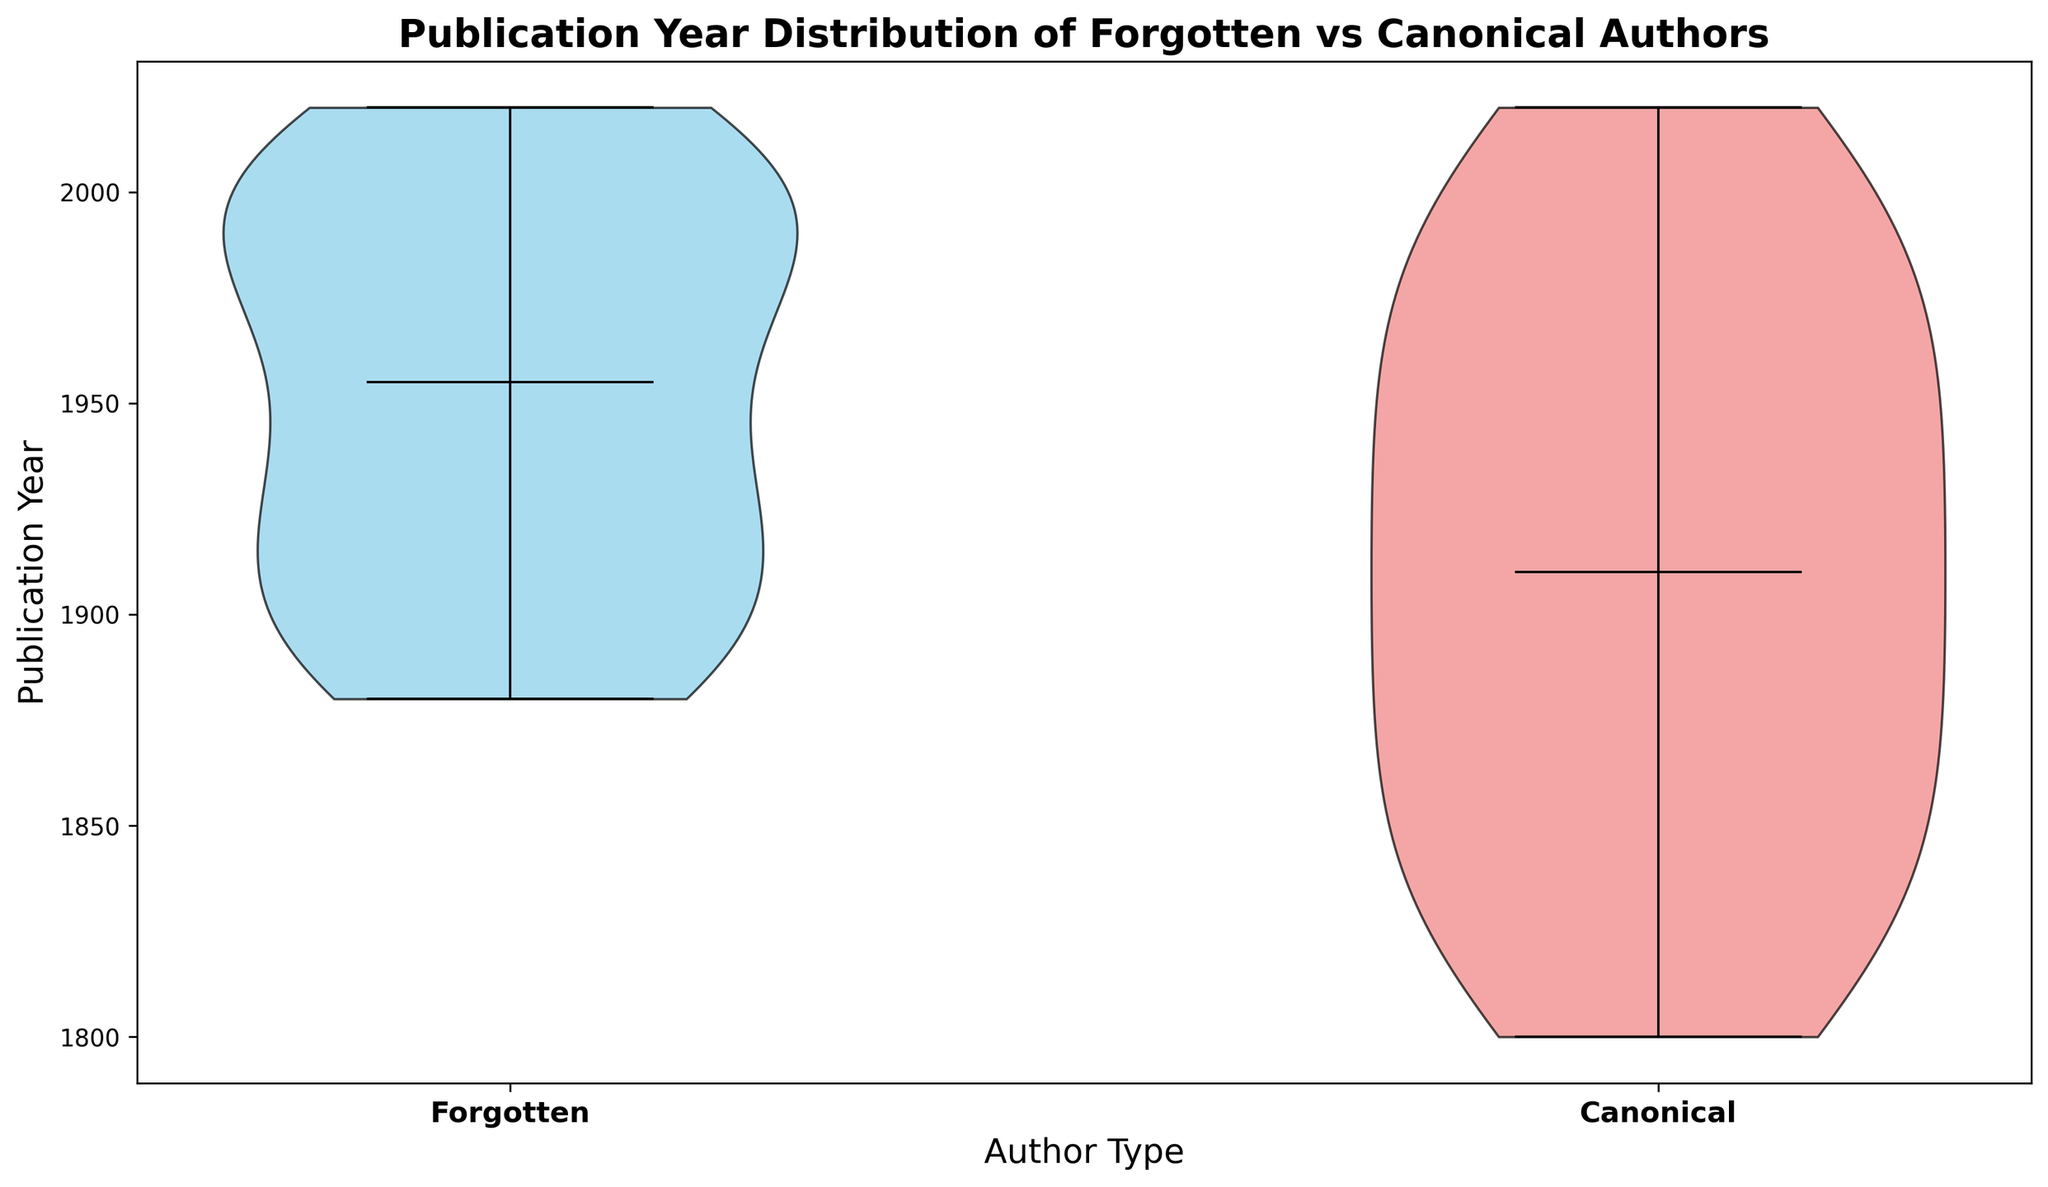What's the median publication year for Forgotten and Canonical authors? The medians can be identified from the violin plot as the points where the median line intersects. Each author type (Forgotten vs Canonical) will have a distinct median on the plot. Look at the center lines in each violin portion of the plot to find the medians for both groups. For Forgotten authors, the median is around 2000, and for Canonical authors, it is around 1900.
Answer: 2000 for Forgotten, 1900 for Canonical In which author category is there a greater spread of publication years? Spread can be observed by the width and overall length of the violin plots. Forgotten authors have publications ranging from 1880 to 2020, whereas Canonical authors have publications ranging from 1800 to 2020. However, Canonical authors have a distinctly broader distribution in the early years than the Forgotten authors.
Answer: Canonical Which author type has more concentrated recent publications? The concentration of recent publications can be identified by the density of the violin plot near the upper end of the publication years. For Forgotten authors, there is a noticeable bulge near the most recent years, indicating a higher concentration compared to Canonical authors.
Answer: Forgotten Are the publication years of Forgotten authors generally more recent compared to Canonical authors? By comparing the overall position of the violin plots along the publication year axis, we can see that the bulk (concentration) of the Forgotten authors' publications is located in more recent years compared to the Canonical authors, who have a broader distribution over older years.
Answer: Yes Which group shows a sharper peak around its median publication year? Sharpness or peak around the median can be observed by the narrowness of the violin plot at the median point. For the Forgotten authors, the violin plot shows a sharper peak around the median (2000) compared to the Canonical authors who have a more even distribution around their median (1900).
Answer: Forgotten Is there any overlap in the publication years between Forgotten and Canonical authors? Overlap can be noted by seeing if there are common year ranges in both violin plots. Both author categories indicate publications spanning 1880 to 2020, resulting in a substantial overlap through this period.
Answer: Yes Which author type demonstrates a higher interquartile range (IQR) in publication years? IQR is the middle 50% of the data. By examining the violin plots, Canonical authors appear to have a wider section around the bulk middle part of the plot, indicating a higher IQR compared to a more narrowly centered IQR for Forgotten authors.
Answer: Canonical Do both author types cover publication years before the 20th century? By looking at the lower end of the publication years on the plot, Canonical authors include publication years starting from 1800, thereby covering pre-20th century years. Forgotten authors start from 1880, not covering the 19th century as extensively.
Answer: No for Forgotten, Yes for Canonical 